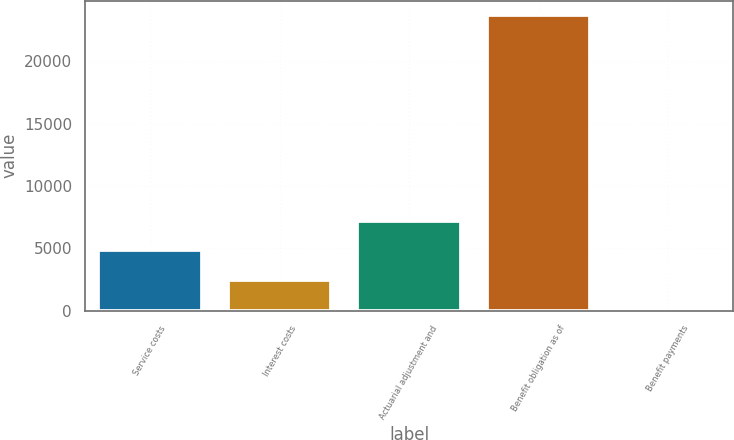<chart> <loc_0><loc_0><loc_500><loc_500><bar_chart><fcel>Service costs<fcel>Interest costs<fcel>Actuarial adjustment and<fcel>Benefit obligation as of<fcel>Benefit payments<nl><fcel>4850.8<fcel>2499.4<fcel>7202.2<fcel>23662<fcel>148<nl></chart> 